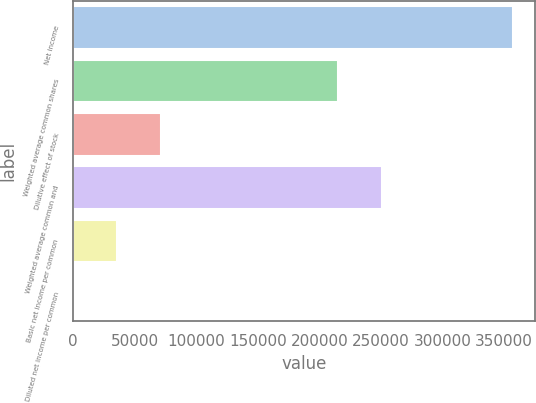<chart> <loc_0><loc_0><loc_500><loc_500><bar_chart><fcel>Net income<fcel>Weighted average common shares<fcel>Dilutive effect of stock<fcel>Weighted average common and<fcel>Basic net income per common<fcel>Diluted net income per common<nl><fcel>357029<fcel>215498<fcel>71407.1<fcel>251201<fcel>35704.4<fcel>1.62<nl></chart> 